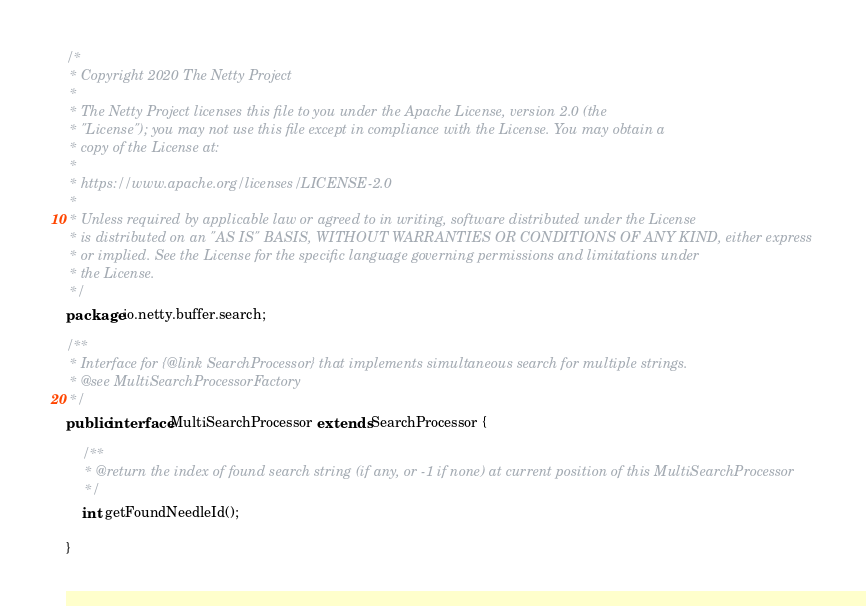<code> <loc_0><loc_0><loc_500><loc_500><_Java_>/*
 * Copyright 2020 The Netty Project
 *
 * The Netty Project licenses this file to you under the Apache License, version 2.0 (the
 * "License"); you may not use this file except in compliance with the License. You may obtain a
 * copy of the License at:
 *
 * https://www.apache.org/licenses/LICENSE-2.0
 *
 * Unless required by applicable law or agreed to in writing, software distributed under the License
 * is distributed on an "AS IS" BASIS, WITHOUT WARRANTIES OR CONDITIONS OF ANY KIND, either express
 * or implied. See the License for the specific language governing permissions and limitations under
 * the License.
 */
package io.netty.buffer.search;

/**
 * Interface for {@link SearchProcessor} that implements simultaneous search for multiple strings.
 * @see MultiSearchProcessorFactory
 */
public interface MultiSearchProcessor extends SearchProcessor {

    /**
     * @return the index of found search string (if any, or -1 if none) at current position of this MultiSearchProcessor
     */
    int getFoundNeedleId();

}
</code> 